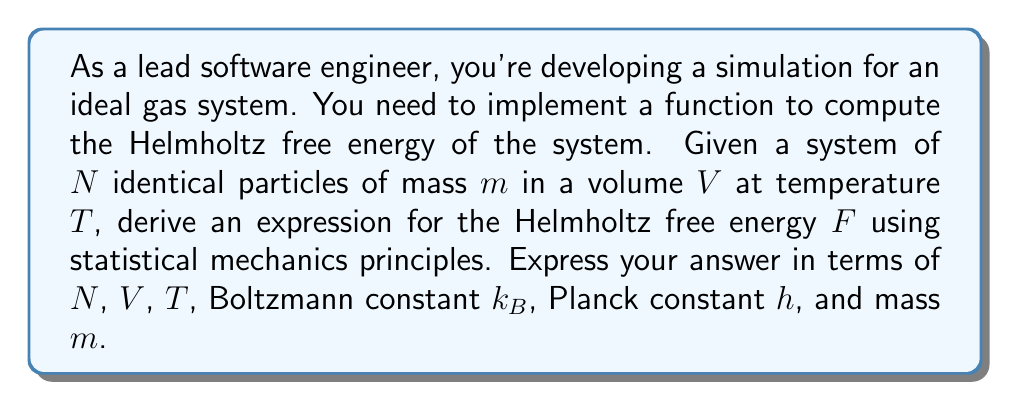Give your solution to this math problem. To compute the Helmholtz free energy $F$ of an ideal gas using statistical mechanics, we'll follow these steps:

1) The Helmholtz free energy is related to the partition function $Z$ by:
   $$F = -k_B T \ln Z$$

2) For an ideal gas, the partition function is:
   $$Z = \frac{1}{N!} \left(\frac{V}{h^3} \int e^{-\beta p^2/2m} d^3p\right)^N$$
   where $\beta = \frac{1}{k_B T}$

3) Evaluate the momentum integral:
   $$\int e^{-\beta p^2/2m} d^3p = \left(\frac{2\pi m}{\beta}\right)^{3/2} = (2\pi m k_B T)^{3/2}$$

4) Substitute this back into the partition function:
   $$Z = \frac{1}{N!} \left(\frac{V}{h^3} (2\pi m k_B T)^{3/2}\right)^N$$

5) Apply Stirling's approximation for large $N$: $\ln N! \approx N \ln N - N$

6) Now, calculate $\ln Z$:
   $$\ln Z \approx N \ln \left(\frac{V}{h^3} (2\pi m k_B T)^{3/2}\right) - (N \ln N - N)$$

7) Substitute this into the free energy equation:
   $$F = -k_B T \left[N \ln \left(\frac{V}{h^3} (2\pi m k_B T)^{3/2}\right) - N \ln N + N\right]$$

8) Simplify and rearrange:
   $$F = -N k_B T \left[\ln \left(\frac{V}{N h^3} (2\pi m k_B T)^{3/2}\right) + 1\right]$$

This is the final expression for the Helmholtz free energy of an ideal gas.
Answer: $$F = -N k_B T \left[\ln \left(\frac{V}{N h^3} (2\pi m k_B T)^{3/2}\right) + 1\right]$$ 